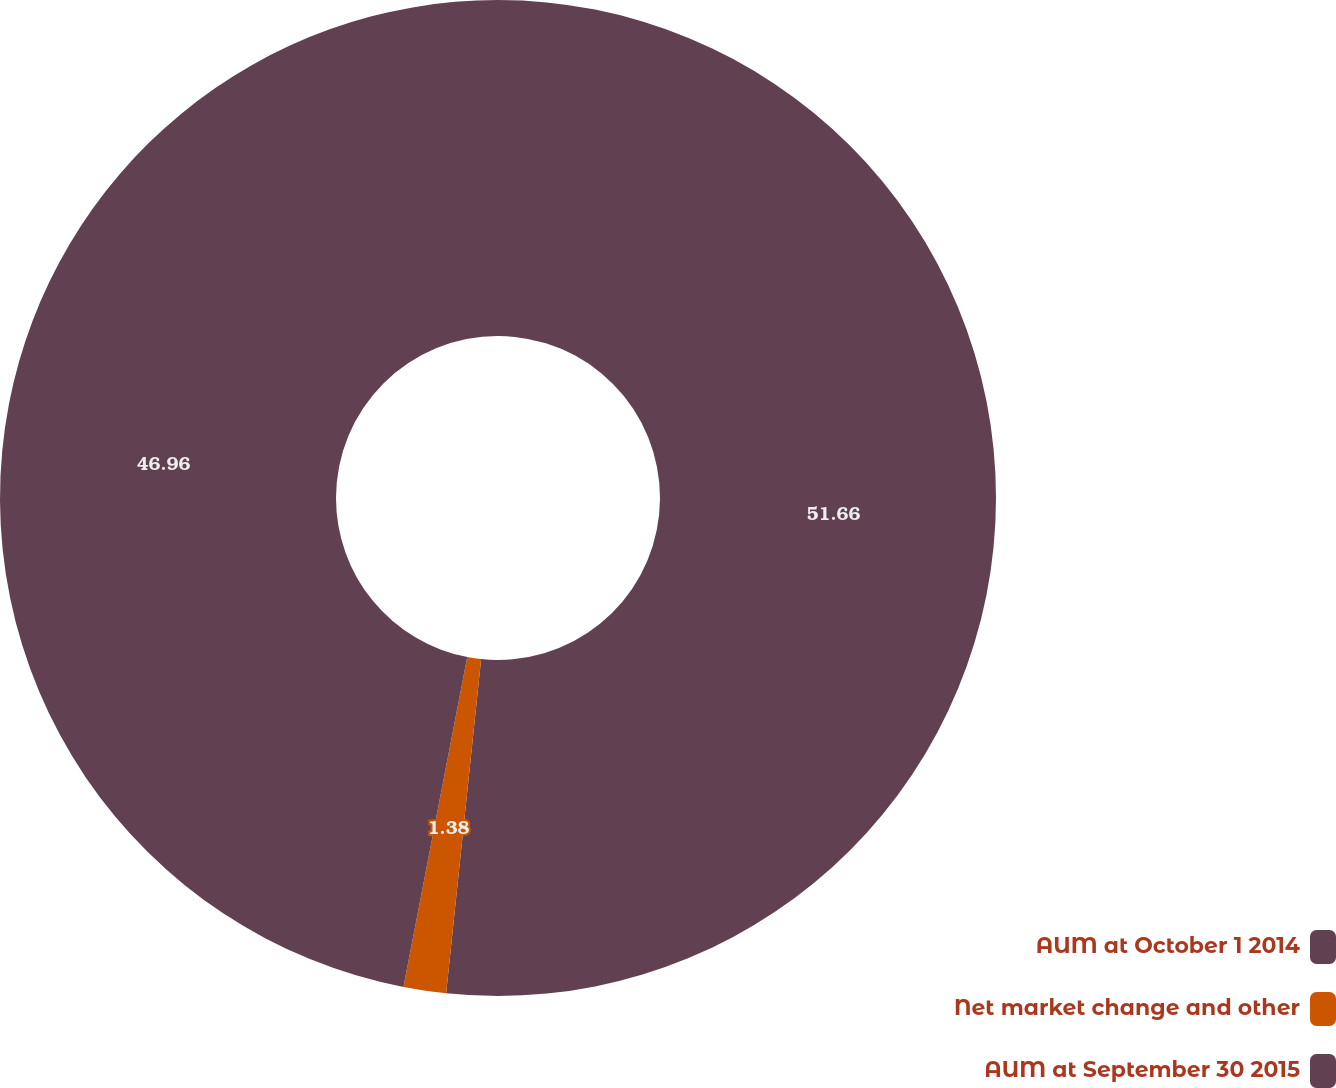Convert chart. <chart><loc_0><loc_0><loc_500><loc_500><pie_chart><fcel>AUM at October 1 2014<fcel>Net market change and other<fcel>AUM at September 30 2015<nl><fcel>51.66%<fcel>1.38%<fcel>46.96%<nl></chart> 